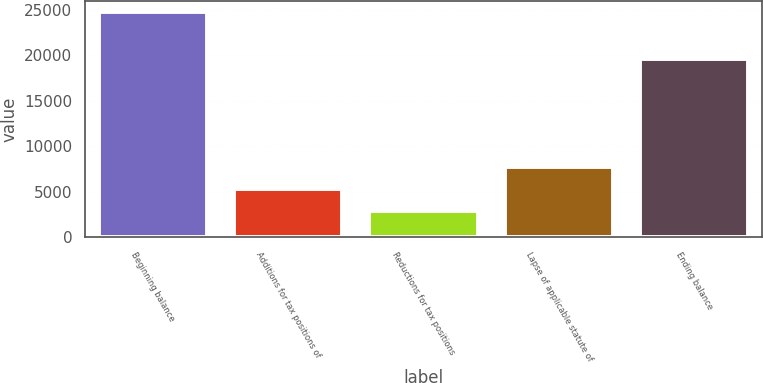<chart> <loc_0><loc_0><loc_500><loc_500><bar_chart><fcel>Beginning balance<fcel>Additions for tax positions of<fcel>Reductions for tax positions<fcel>Lapse of applicable statute of<fcel>Ending balance<nl><fcel>24765<fcel>5329<fcel>2899.5<fcel>7758.5<fcel>19556<nl></chart> 